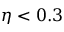<formula> <loc_0><loc_0><loc_500><loc_500>\eta < 0 . 3</formula> 